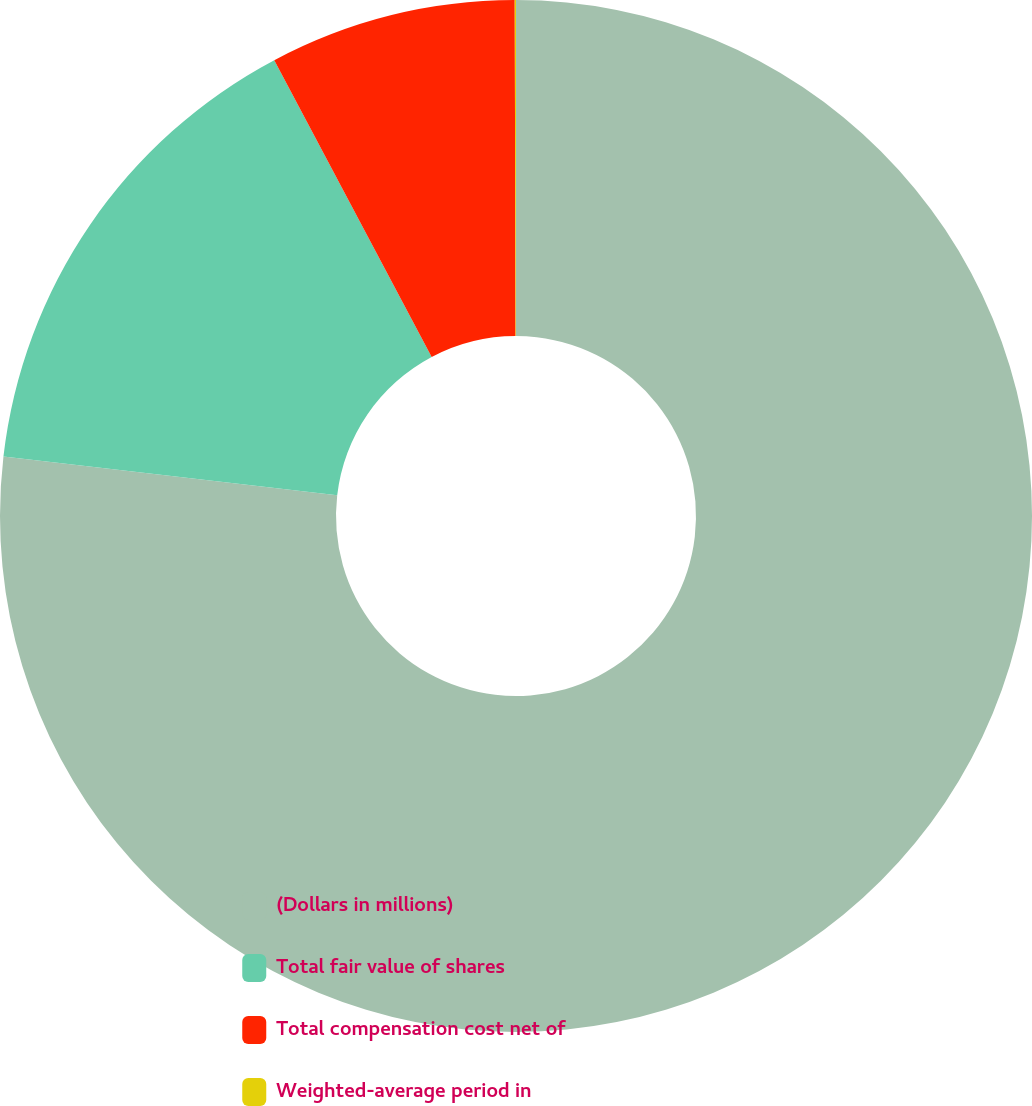<chart> <loc_0><loc_0><loc_500><loc_500><pie_chart><fcel>(Dollars in millions)<fcel>Total fair value of shares<fcel>Total compensation cost net of<fcel>Weighted-average period in<nl><fcel>76.84%<fcel>15.4%<fcel>7.72%<fcel>0.04%<nl></chart> 